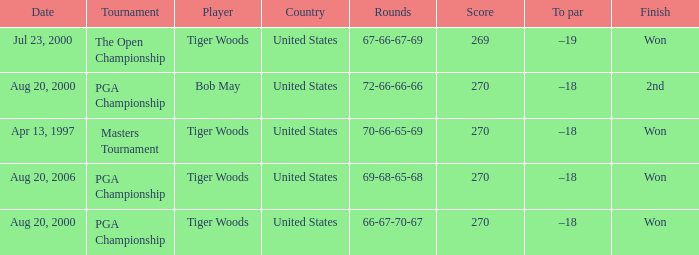What country hosts the tournament the open championship? United States. 